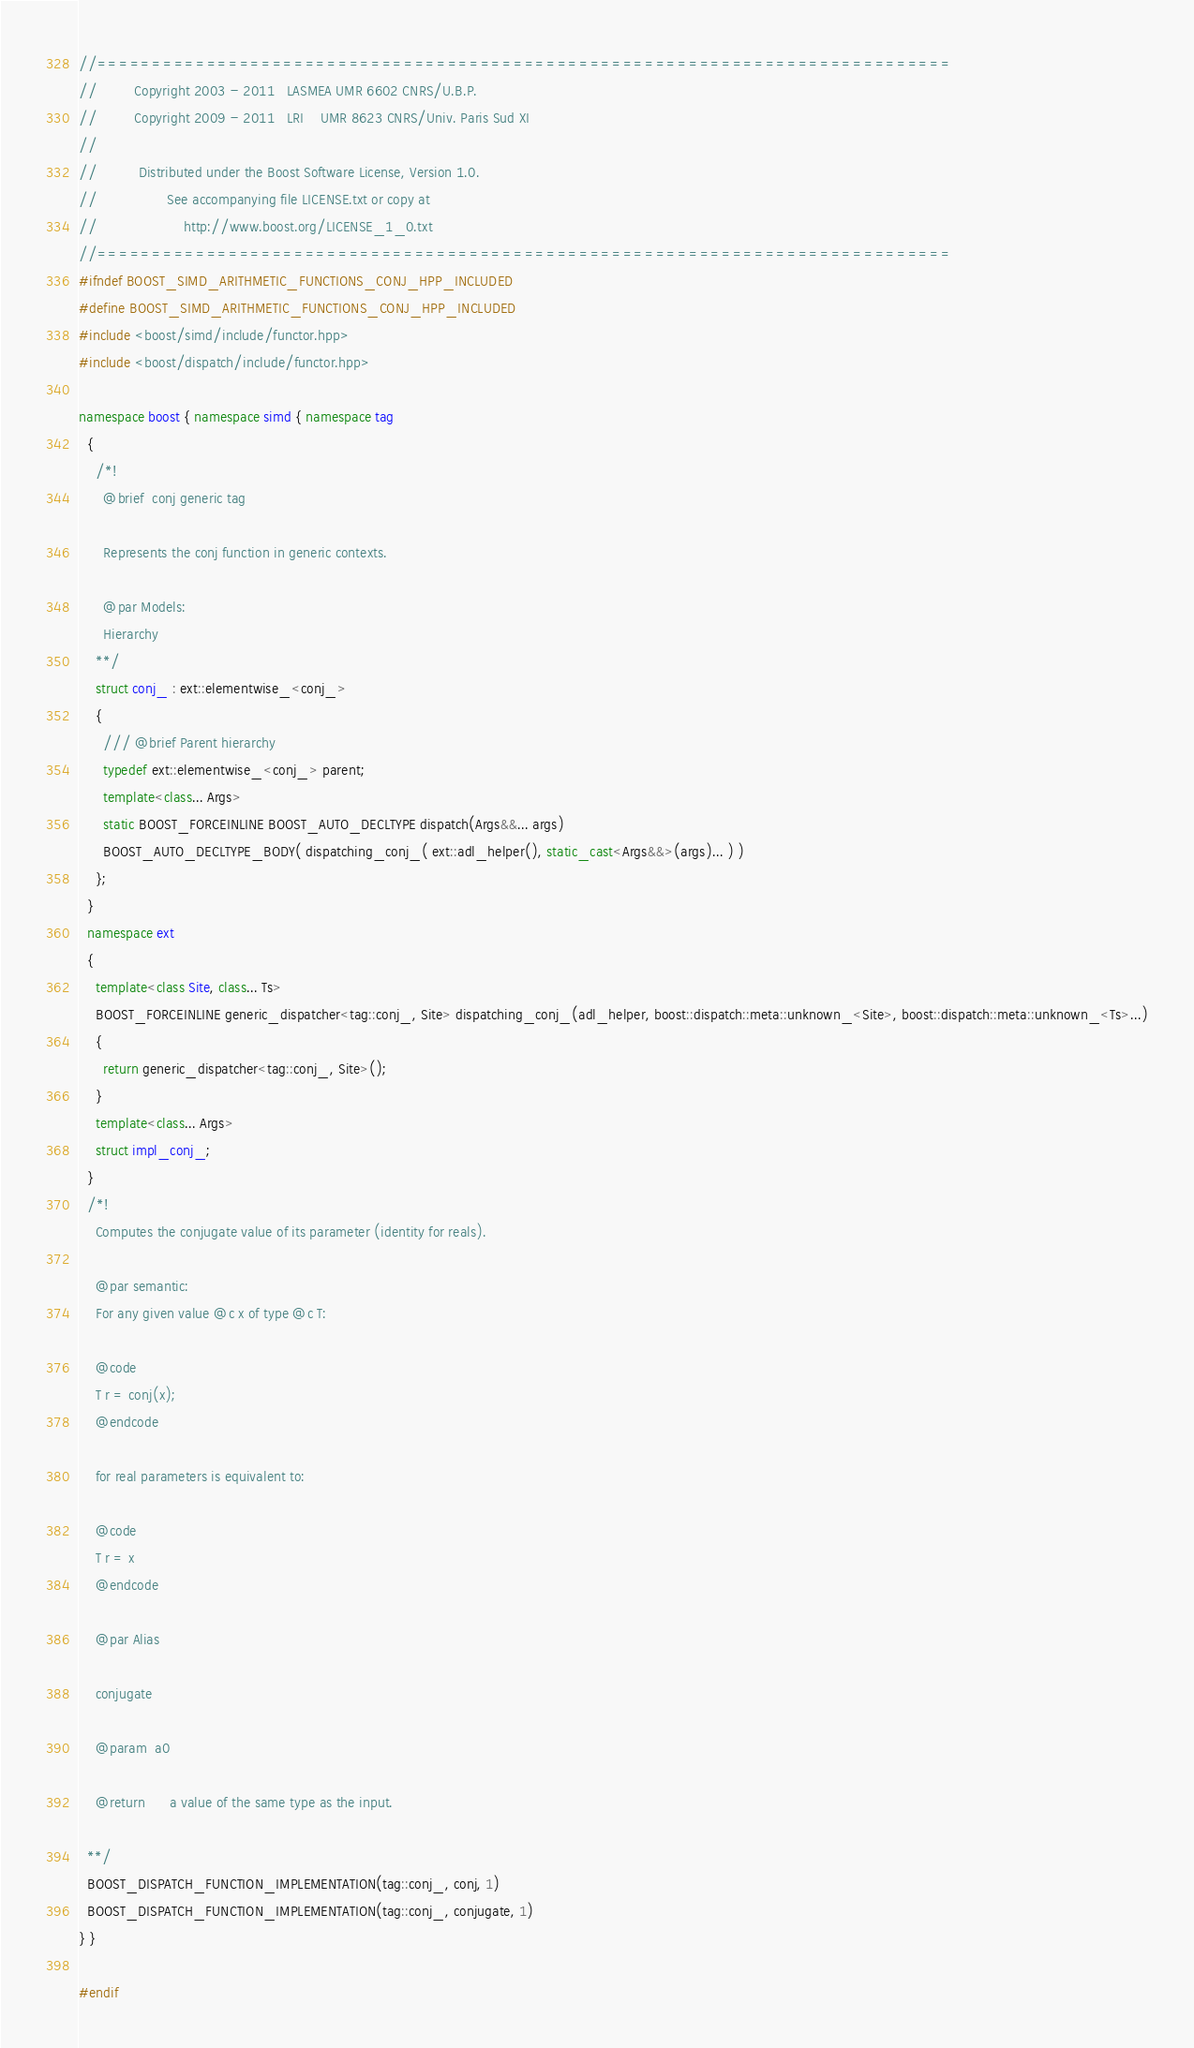Convert code to text. <code><loc_0><loc_0><loc_500><loc_500><_C++_>//==============================================================================
//         Copyright 2003 - 2011   LASMEA UMR 6602 CNRS/U.B.P.
//         Copyright 2009 - 2011   LRI    UMR 8623 CNRS/Univ. Paris Sud XI
//
//          Distributed under the Boost Software License, Version 1.0.
//                 See accompanying file LICENSE.txt or copy at
//                     http://www.boost.org/LICENSE_1_0.txt
//==============================================================================
#ifndef BOOST_SIMD_ARITHMETIC_FUNCTIONS_CONJ_HPP_INCLUDED
#define BOOST_SIMD_ARITHMETIC_FUNCTIONS_CONJ_HPP_INCLUDED
#include <boost/simd/include/functor.hpp>
#include <boost/dispatch/include/functor.hpp>

namespace boost { namespace simd { namespace tag
  {
    /*!
      @brief  conj generic tag

      Represents the conj function in generic contexts.

      @par Models:
      Hierarchy
    **/
    struct conj_ : ext::elementwise_<conj_>
    {
      /// @brief Parent hierarchy
      typedef ext::elementwise_<conj_> parent;
      template<class... Args>
      static BOOST_FORCEINLINE BOOST_AUTO_DECLTYPE dispatch(Args&&... args)
      BOOST_AUTO_DECLTYPE_BODY( dispatching_conj_( ext::adl_helper(), static_cast<Args&&>(args)... ) )
    };
  }
  namespace ext
  {
    template<class Site, class... Ts>
    BOOST_FORCEINLINE generic_dispatcher<tag::conj_, Site> dispatching_conj_(adl_helper, boost::dispatch::meta::unknown_<Site>, boost::dispatch::meta::unknown_<Ts>...)
    {
      return generic_dispatcher<tag::conj_, Site>();
    }
    template<class... Args>
    struct impl_conj_;
  }
  /*!
    Computes the conjugate value of its parameter (identity for reals).

    @par semantic:
    For any given value @c x of type @c T:

    @code
    T r = conj(x);
    @endcode

    for real parameters is equivalent to:

    @code
    T r = x
    @endcode

    @par Alias

    conjugate

    @param  a0

    @return      a value of the same type as the input.

  **/
  BOOST_DISPATCH_FUNCTION_IMPLEMENTATION(tag::conj_, conj, 1)
  BOOST_DISPATCH_FUNCTION_IMPLEMENTATION(tag::conj_, conjugate, 1)
} }

#endif

</code> 